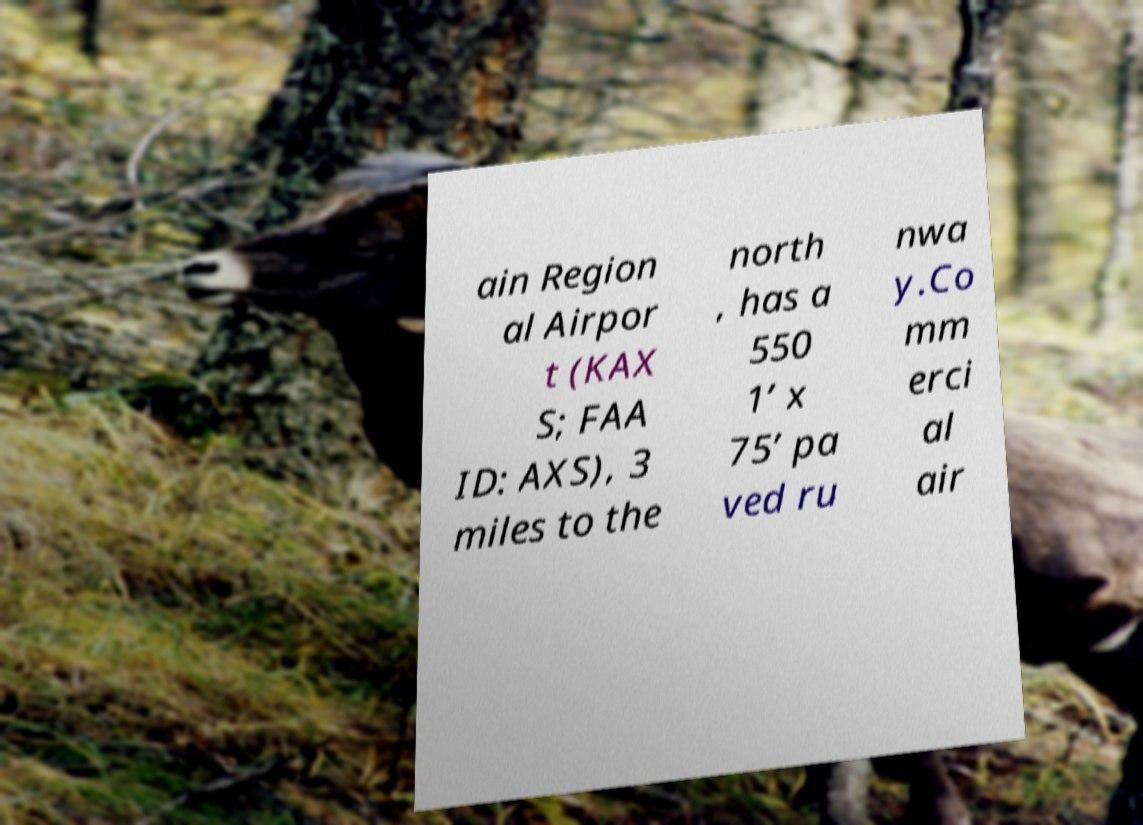For documentation purposes, I need the text within this image transcribed. Could you provide that? ain Region al Airpor t (KAX S; FAA ID: AXS), 3 miles to the north , has a 550 1’ x 75’ pa ved ru nwa y.Co mm erci al air 